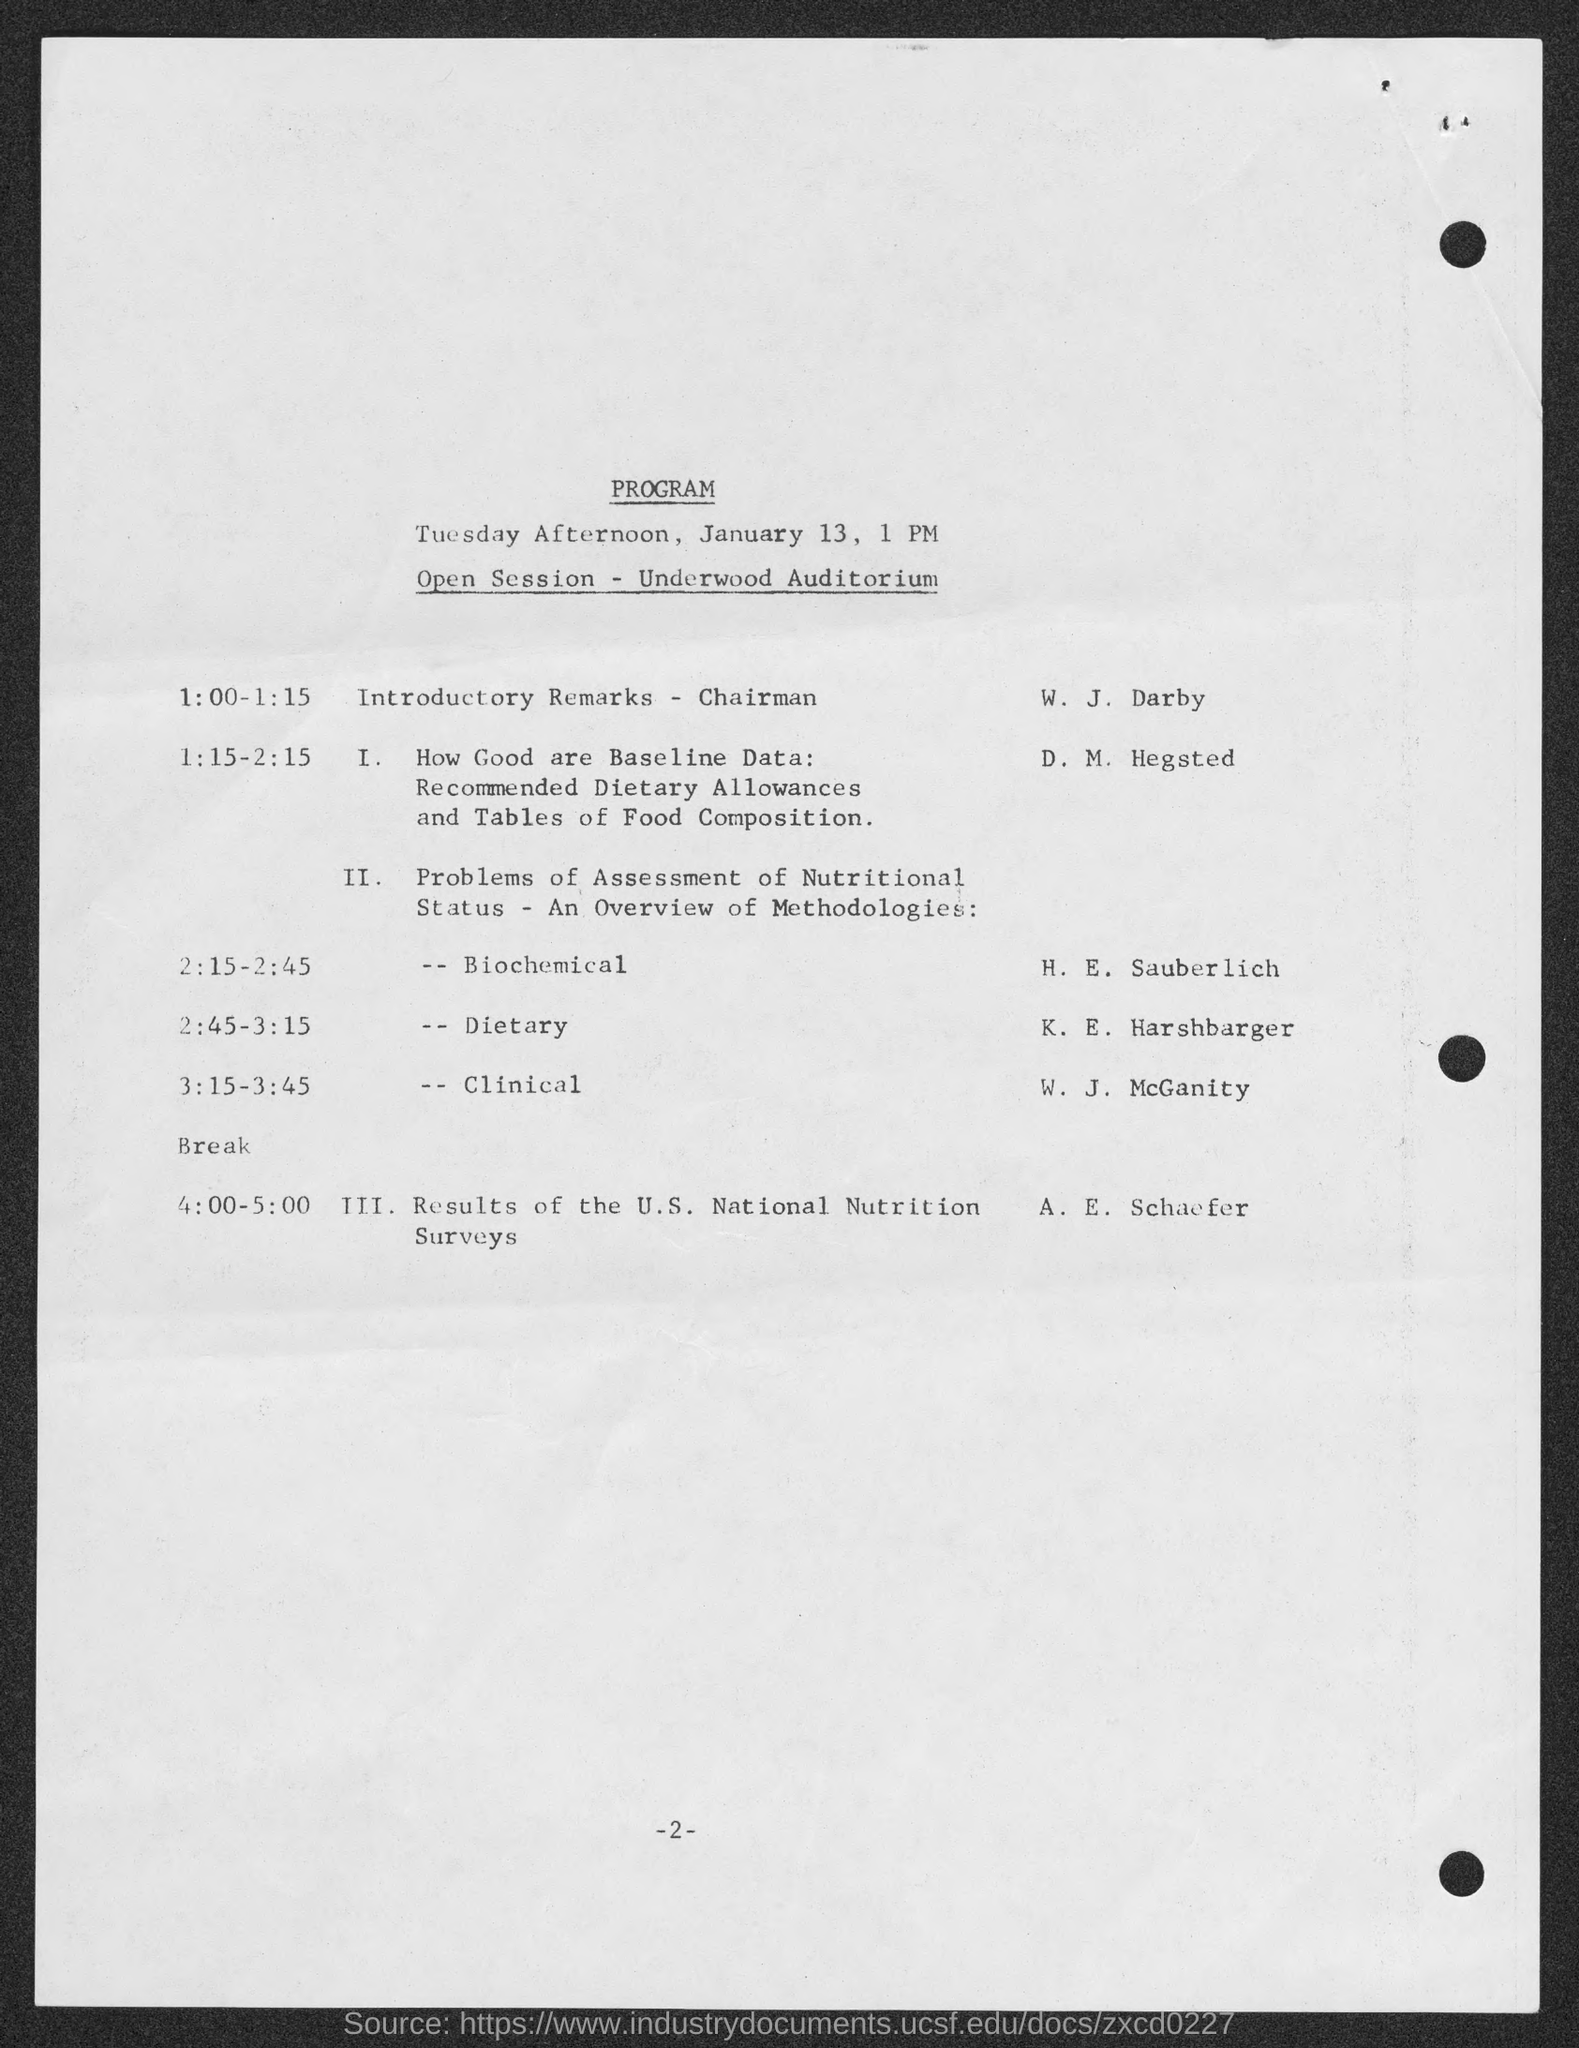Who is giving introductory remarks?
Give a very brief answer. W. J. Darby. 